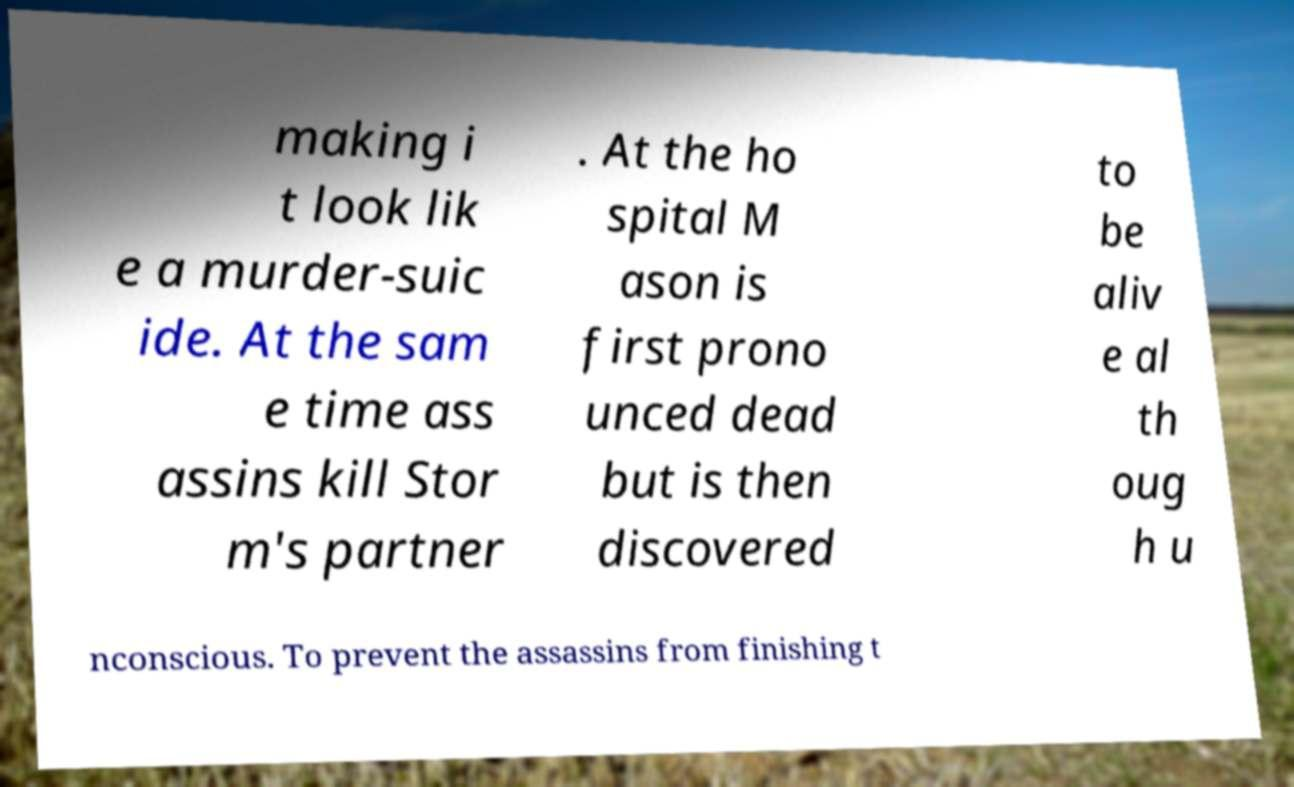What messages or text are displayed in this image? I need them in a readable, typed format. making i t look lik e a murder-suic ide. At the sam e time ass assins kill Stor m's partner . At the ho spital M ason is first prono unced dead but is then discovered to be aliv e al th oug h u nconscious. To prevent the assassins from finishing t 